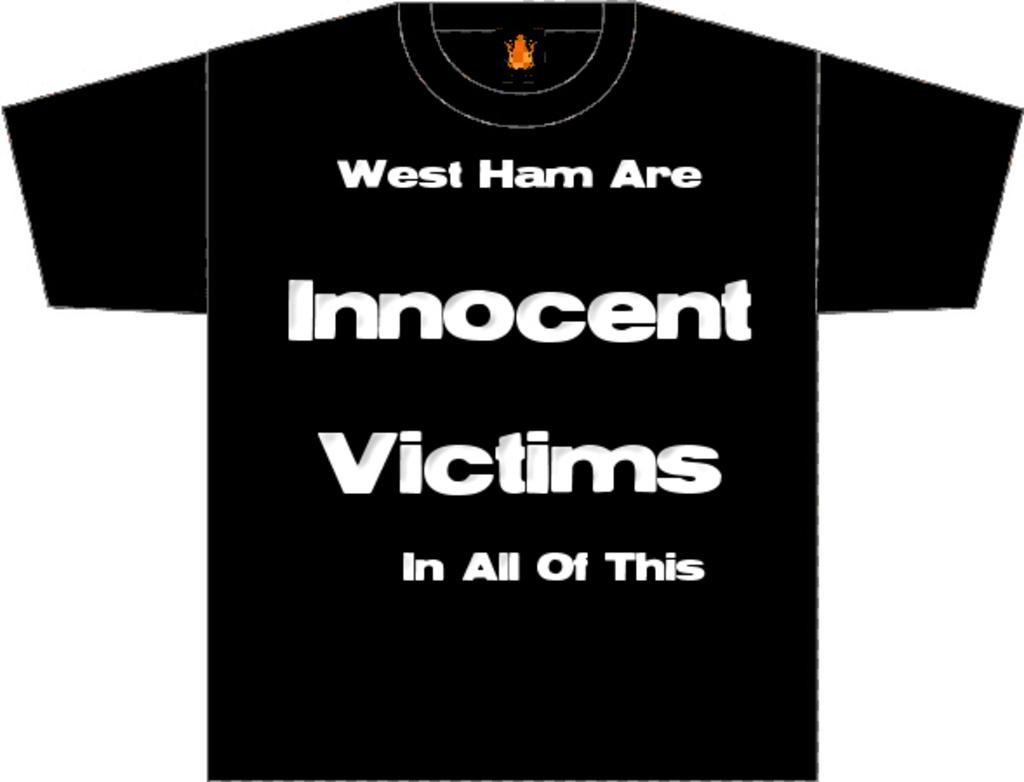What type of clothing item is in the image? There is a T-shirt in the image. What is written or printed on the T-shirt? The T-shirt has text on it. What is the color of the background in the image? There is a white background in the image. How many errors can be found on the T-shirt in the image? There is no mention of any errors on the T-shirt in the image, so it cannot be determined from the image. 